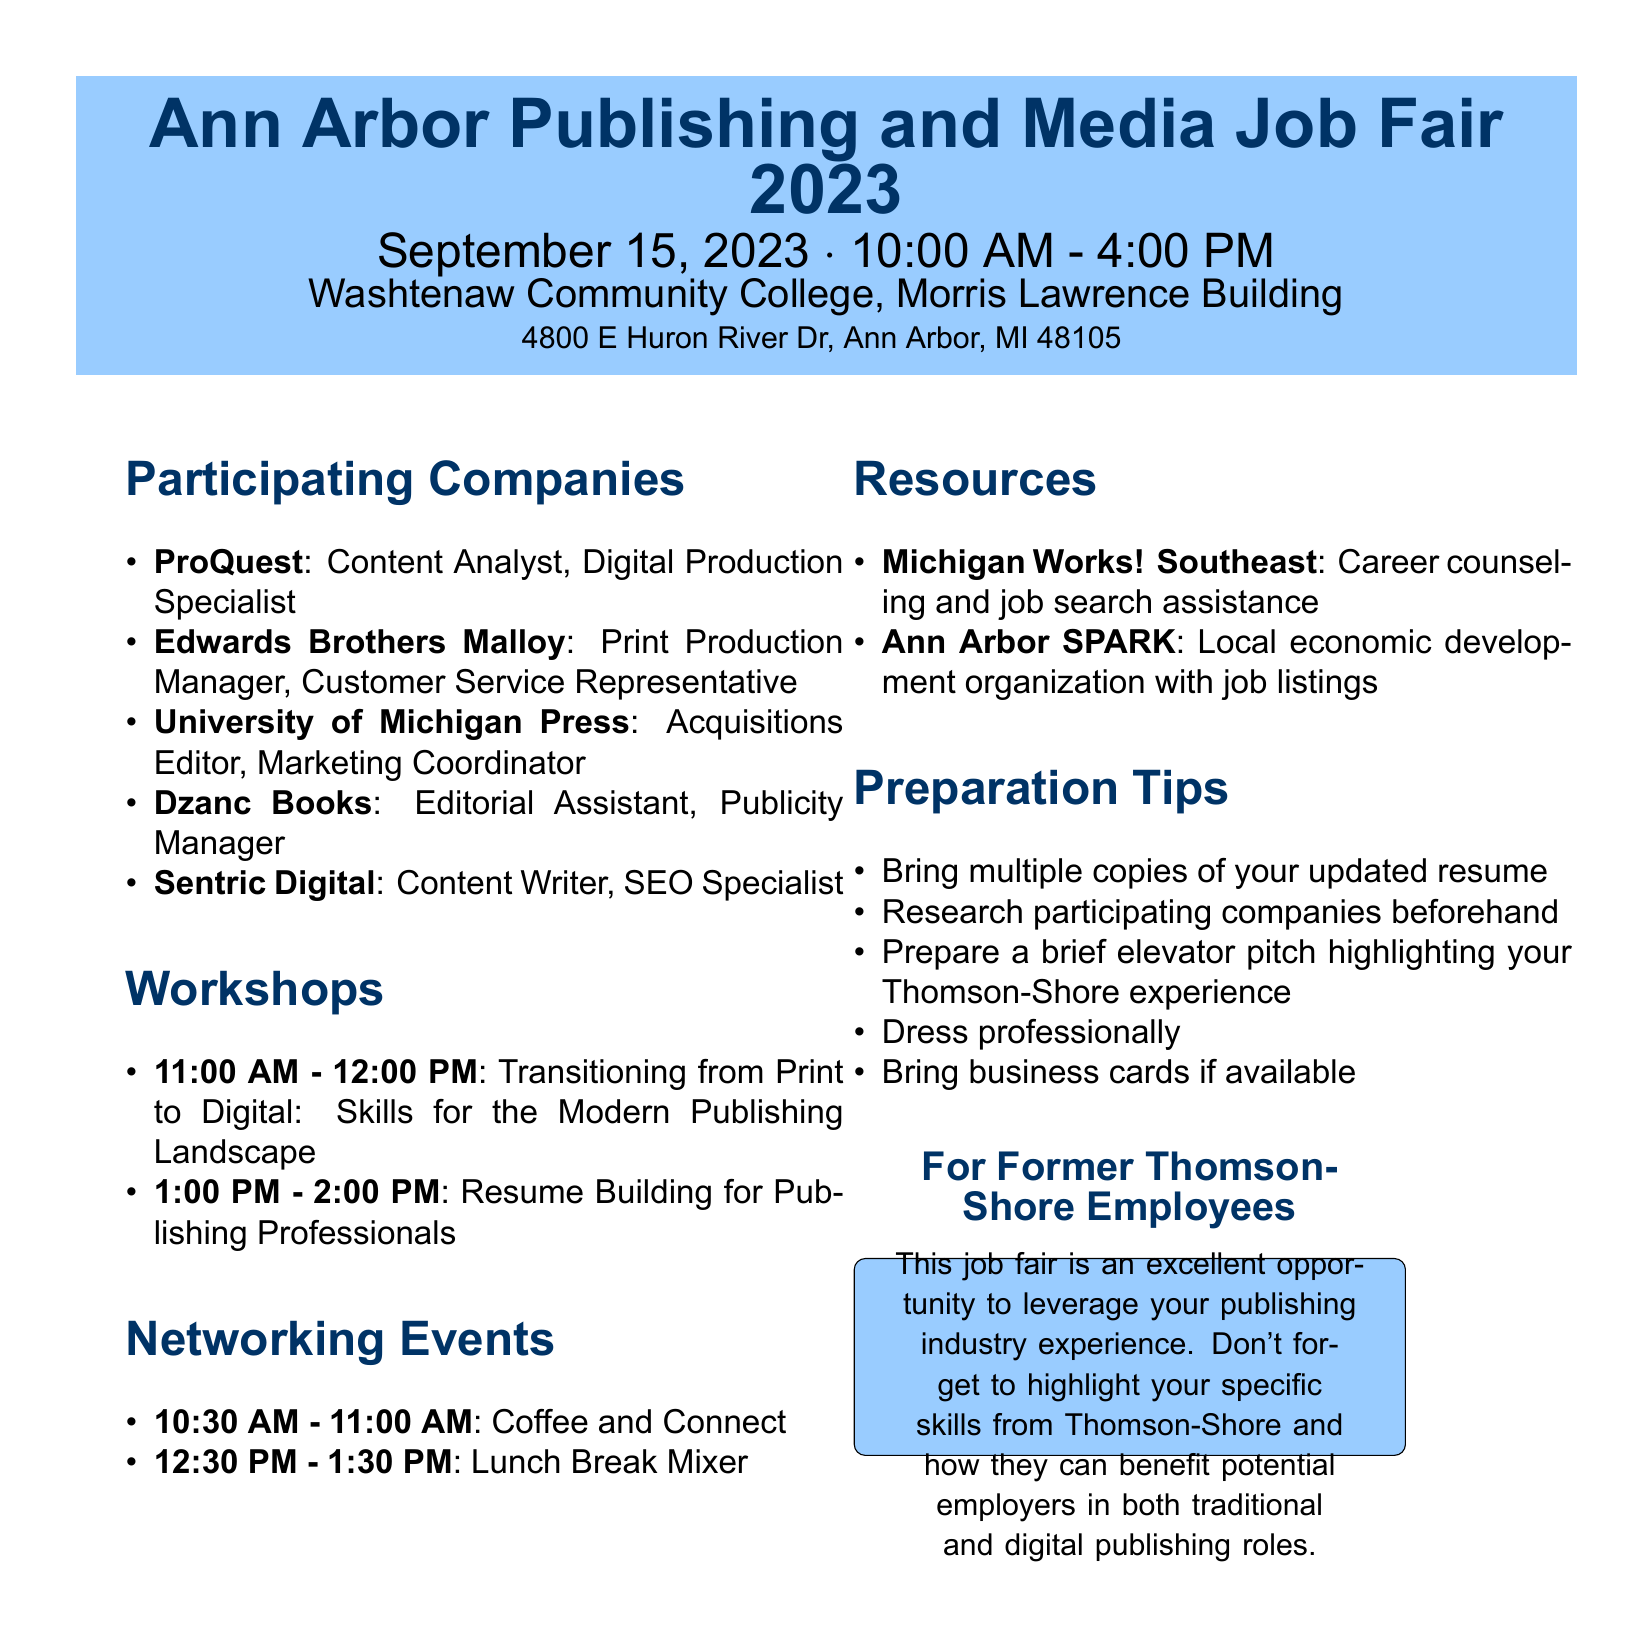What is the date of the job fair? The date of the job fair is specified in the document.
Answer: September 15, 2023 Where is the job fair located? The location of the job fair is provided in the document.
Answer: Washtenaw Community College, Morris Lawrence Building How many positions are available at ProQuest? The document lists the positions available at ProQuest, which are two.
Answer: 2 What workshop starts at 1:00 PM? The document mentions the title and time of the workshops.
Answer: Resume Building for Publishing Professionals Which industry does Dzanc Books belong to? The industry for Dzanc Books is listed in the document.
Answer: Independent publishing What type of resources does Michigan Works! Southeast provide? The document includes a description of the services offered by Michigan Works! Southeast.
Answer: Career counseling and job search assistance What is one preparation tip mentioned in the document? Several preparation tips are given in the document for attendees.
Answer: Bring multiple copies of your updated resume How long does the Lunch Break Mixer last? The duration of the Lunch Break Mixer is indicated in the schedule.
Answer: 1 hour 